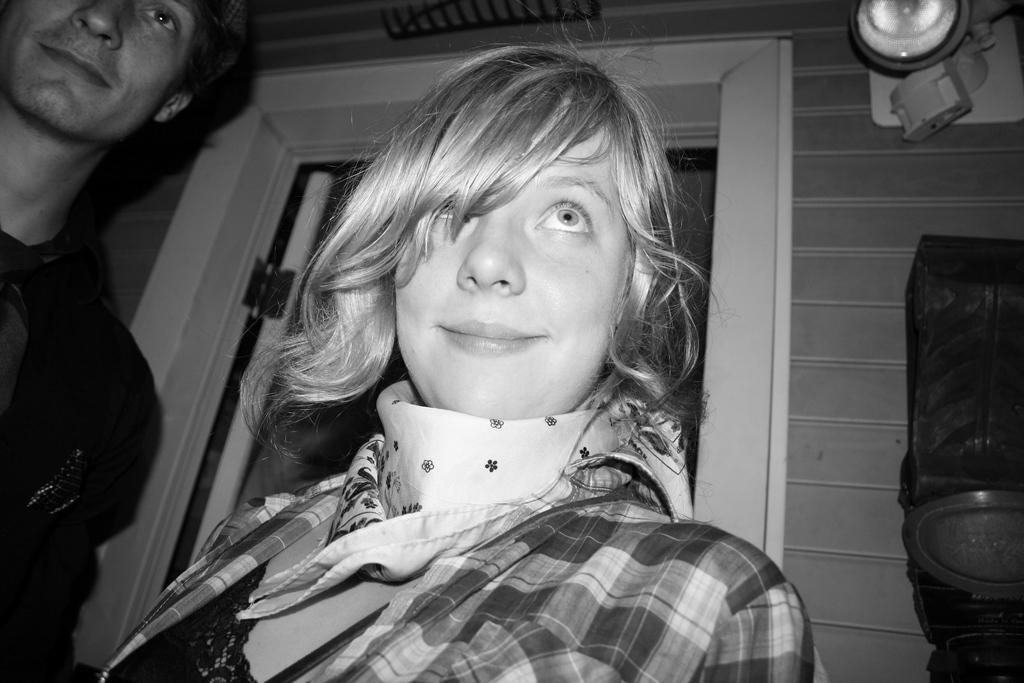In one or two sentences, can you explain what this image depicts? This is a black and white image where we can see a man and a woman. In the background, we can see the door and the wall. There is an object on the right side of the image. We can see a light in the right top of the image. 